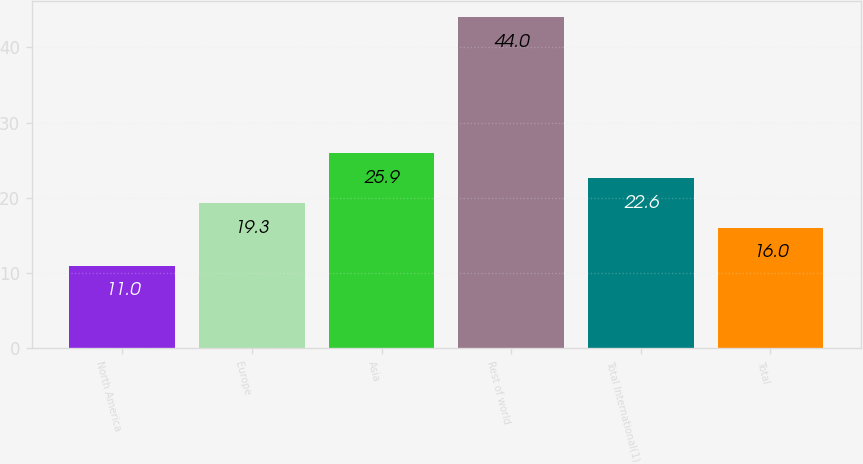Convert chart to OTSL. <chart><loc_0><loc_0><loc_500><loc_500><bar_chart><fcel>North America<fcel>Europe<fcel>Asia<fcel>Rest of world<fcel>Total International(1)<fcel>Total<nl><fcel>11<fcel>19.3<fcel>25.9<fcel>44<fcel>22.6<fcel>16<nl></chart> 